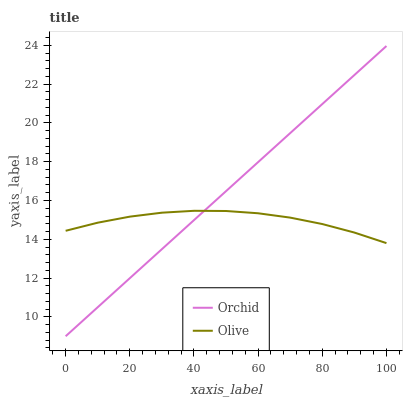Does Orchid have the minimum area under the curve?
Answer yes or no. No. Is Orchid the roughest?
Answer yes or no. No. 